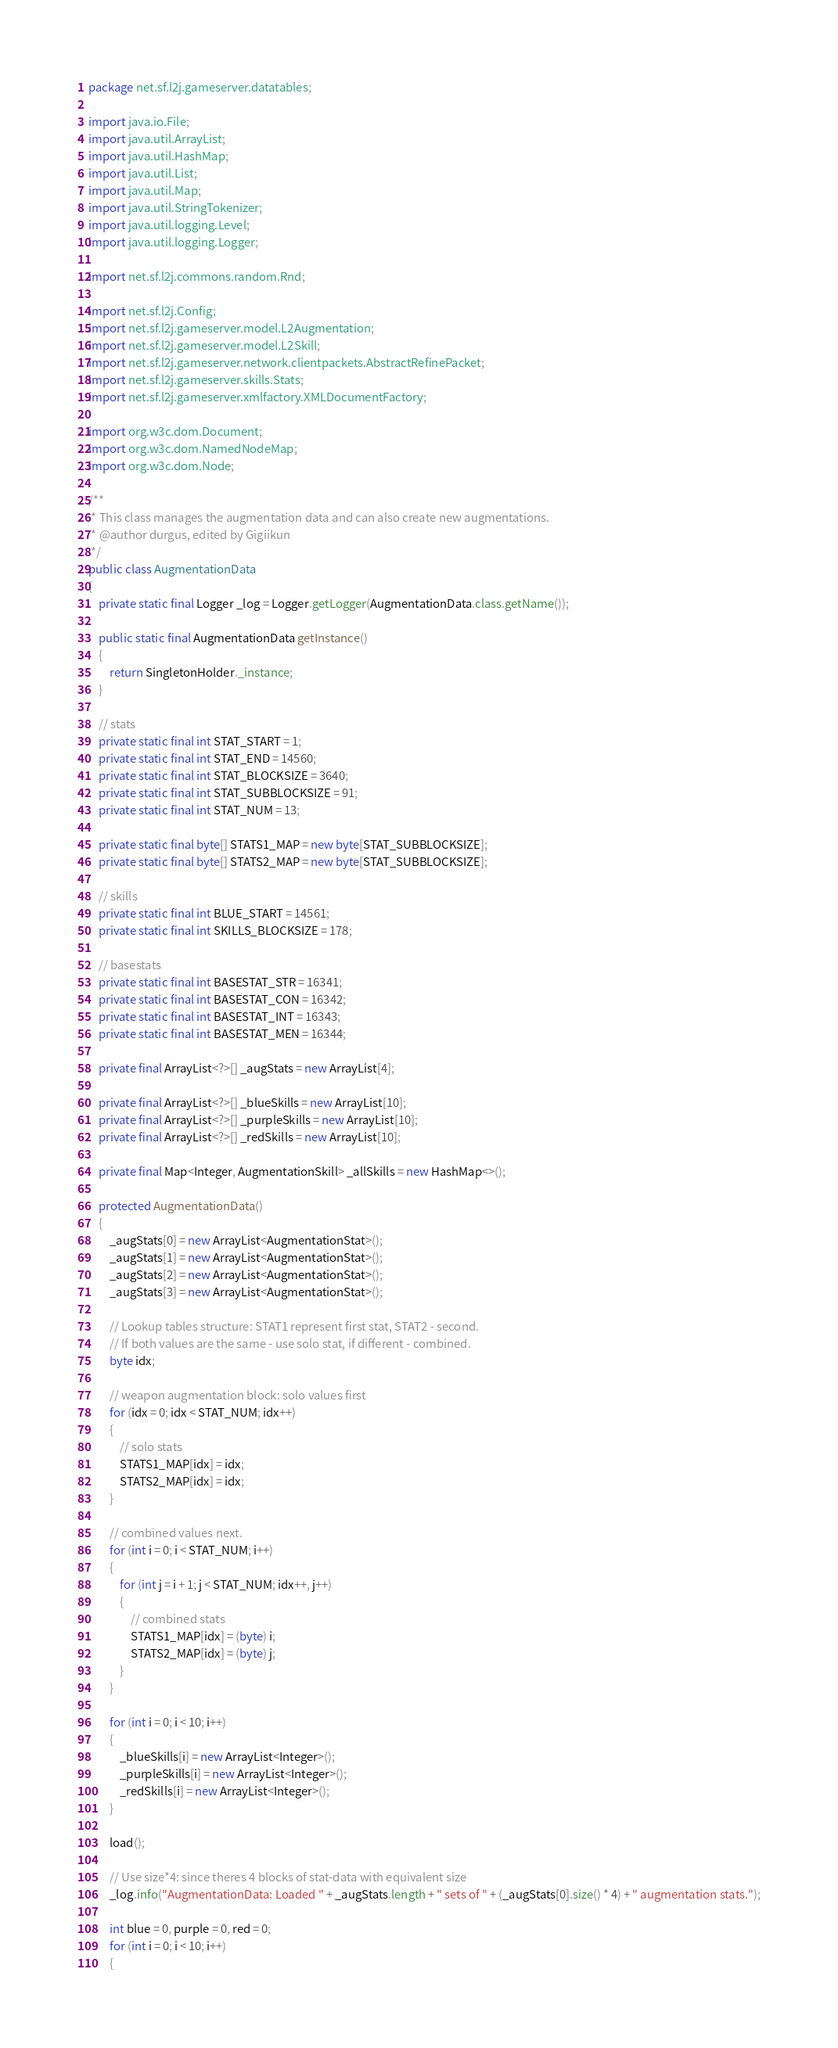<code> <loc_0><loc_0><loc_500><loc_500><_Java_>package net.sf.l2j.gameserver.datatables;

import java.io.File;
import java.util.ArrayList;
import java.util.HashMap;
import java.util.List;
import java.util.Map;
import java.util.StringTokenizer;
import java.util.logging.Level;
import java.util.logging.Logger;

import net.sf.l2j.commons.random.Rnd;

import net.sf.l2j.Config;
import net.sf.l2j.gameserver.model.L2Augmentation;
import net.sf.l2j.gameserver.model.L2Skill;
import net.sf.l2j.gameserver.network.clientpackets.AbstractRefinePacket;
import net.sf.l2j.gameserver.skills.Stats;
import net.sf.l2j.gameserver.xmlfactory.XMLDocumentFactory;

import org.w3c.dom.Document;
import org.w3c.dom.NamedNodeMap;
import org.w3c.dom.Node;

/**
 * This class manages the augmentation data and can also create new augmentations.
 * @author durgus, edited by Gigiikun
 */
public class AugmentationData
{
	private static final Logger _log = Logger.getLogger(AugmentationData.class.getName());
	
	public static final AugmentationData getInstance()
	{
		return SingletonHolder._instance;
	}
	
	// stats
	private static final int STAT_START = 1;
	private static final int STAT_END = 14560;
	private static final int STAT_BLOCKSIZE = 3640;
	private static final int STAT_SUBBLOCKSIZE = 91;
	private static final int STAT_NUM = 13;
	
	private static final byte[] STATS1_MAP = new byte[STAT_SUBBLOCKSIZE];
	private static final byte[] STATS2_MAP = new byte[STAT_SUBBLOCKSIZE];
	
	// skills
	private static final int BLUE_START = 14561;
	private static final int SKILLS_BLOCKSIZE = 178;
	
	// basestats
	private static final int BASESTAT_STR = 16341;
	private static final int BASESTAT_CON = 16342;
	private static final int BASESTAT_INT = 16343;
	private static final int BASESTAT_MEN = 16344;
	
	private final ArrayList<?>[] _augStats = new ArrayList[4];
	
	private final ArrayList<?>[] _blueSkills = new ArrayList[10];
	private final ArrayList<?>[] _purpleSkills = new ArrayList[10];
	private final ArrayList<?>[] _redSkills = new ArrayList[10];
	
	private final Map<Integer, AugmentationSkill> _allSkills = new HashMap<>();
	
	protected AugmentationData()
	{
		_augStats[0] = new ArrayList<AugmentationStat>();
		_augStats[1] = new ArrayList<AugmentationStat>();
		_augStats[2] = new ArrayList<AugmentationStat>();
		_augStats[3] = new ArrayList<AugmentationStat>();
		
		// Lookup tables structure: STAT1 represent first stat, STAT2 - second.
		// If both values are the same - use solo stat, if different - combined.
		byte idx;
		
		// weapon augmentation block: solo values first
		for (idx = 0; idx < STAT_NUM; idx++)
		{
			// solo stats
			STATS1_MAP[idx] = idx;
			STATS2_MAP[idx] = idx;
		}
		
		// combined values next.
		for (int i = 0; i < STAT_NUM; i++)
		{
			for (int j = i + 1; j < STAT_NUM; idx++, j++)
			{
				// combined stats
				STATS1_MAP[idx] = (byte) i;
				STATS2_MAP[idx] = (byte) j;
			}
		}
		
		for (int i = 0; i < 10; i++)
		{
			_blueSkills[i] = new ArrayList<Integer>();
			_purpleSkills[i] = new ArrayList<Integer>();
			_redSkills[i] = new ArrayList<Integer>();
		}
		
		load();
		
		// Use size*4: since theres 4 blocks of stat-data with equivalent size
		_log.info("AugmentationData: Loaded " + _augStats.length + " sets of " + (_augStats[0].size() * 4) + " augmentation stats.");
		
		int blue = 0, purple = 0, red = 0;
		for (int i = 0; i < 10; i++)
		{</code> 